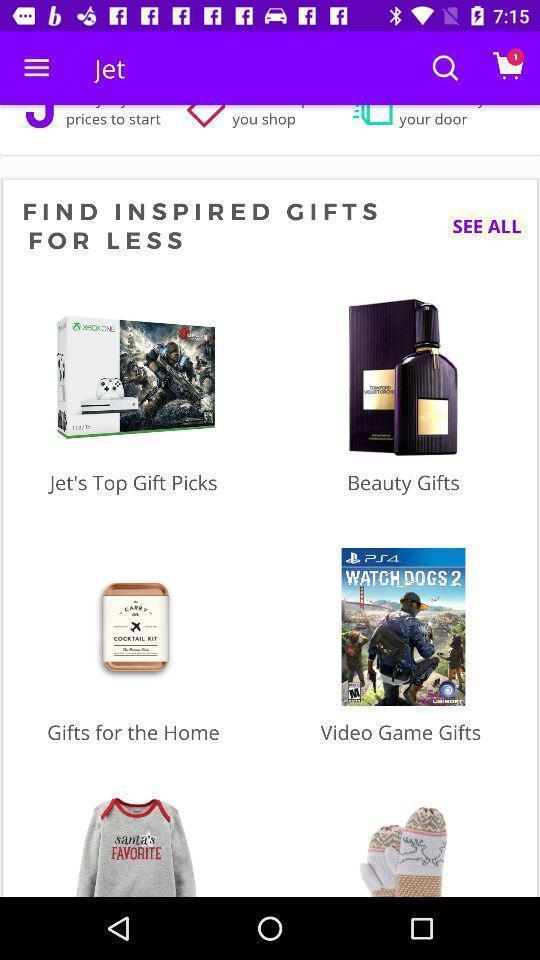Describe the visual elements of this screenshot. Page showing search icon s. 